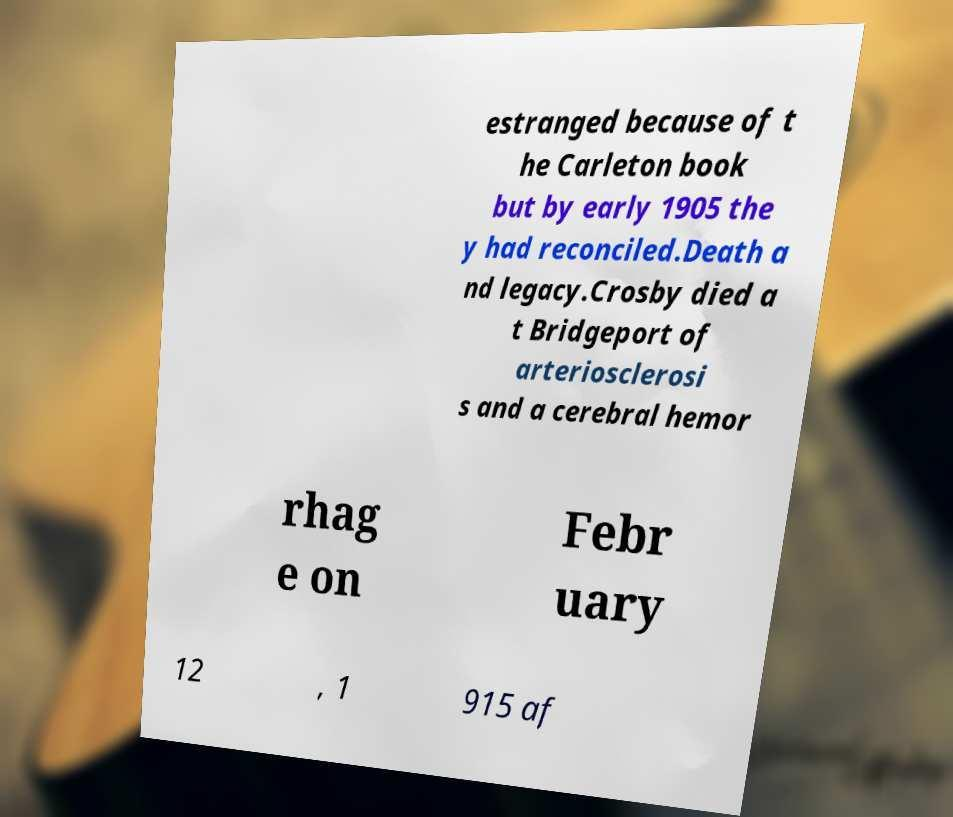What messages or text are displayed in this image? I need them in a readable, typed format. estranged because of t he Carleton book but by early 1905 the y had reconciled.Death a nd legacy.Crosby died a t Bridgeport of arteriosclerosi s and a cerebral hemor rhag e on Febr uary 12 , 1 915 af 